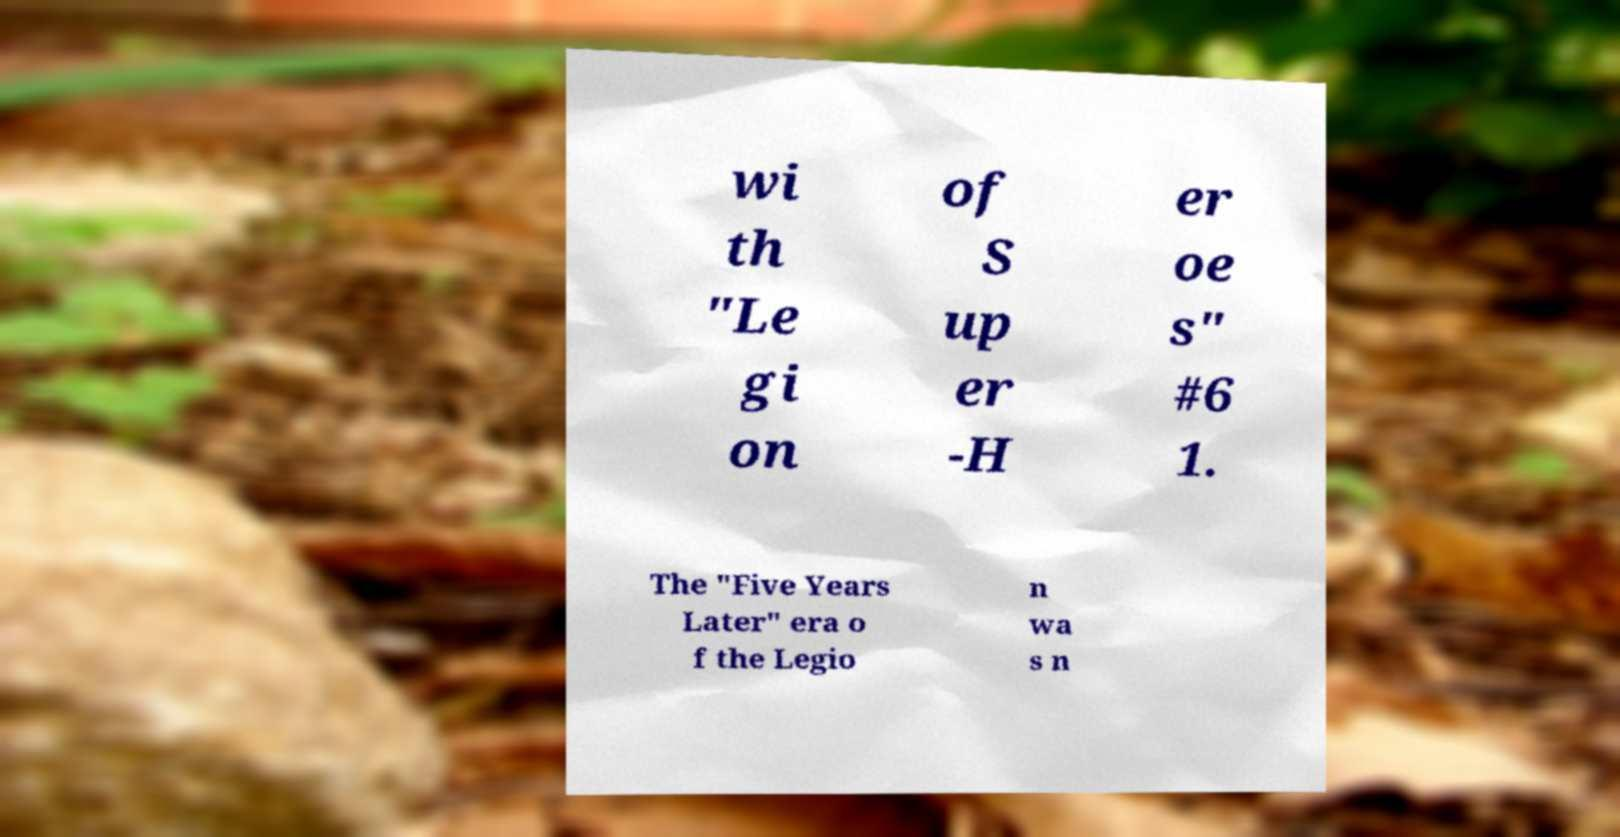Could you extract and type out the text from this image? wi th "Le gi on of S up er -H er oe s" #6 1. The "Five Years Later" era o f the Legio n wa s n 